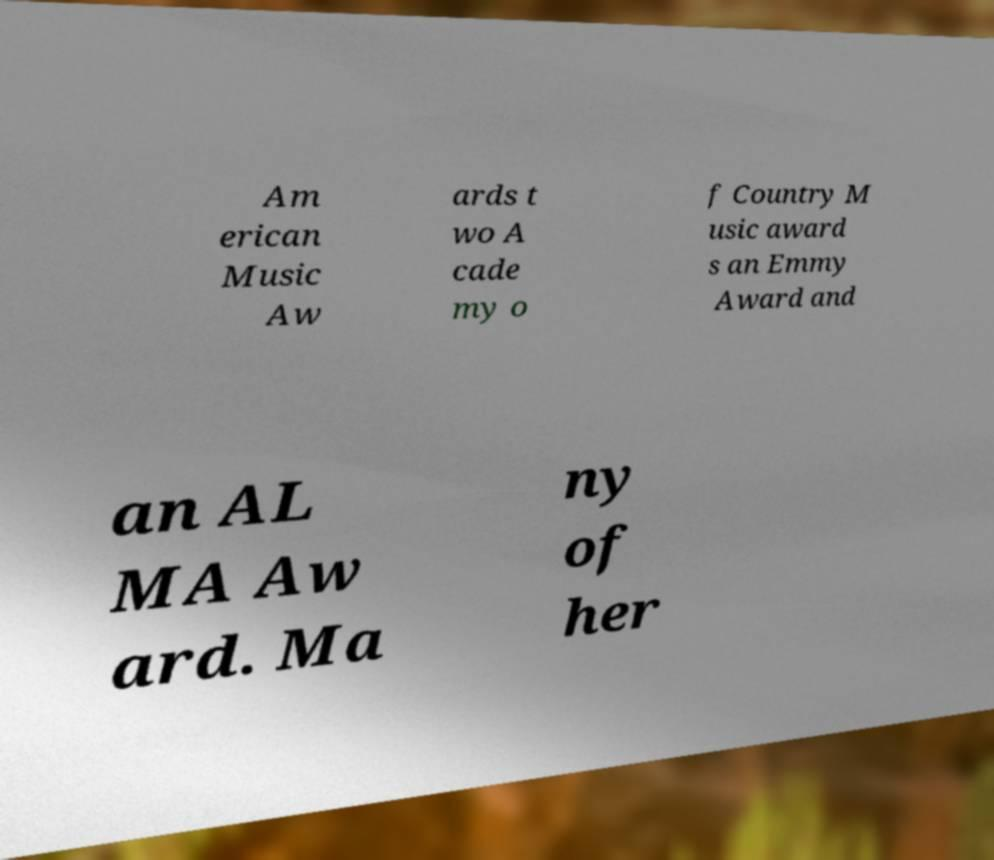Can you accurately transcribe the text from the provided image for me? Am erican Music Aw ards t wo A cade my o f Country M usic award s an Emmy Award and an AL MA Aw ard. Ma ny of her 